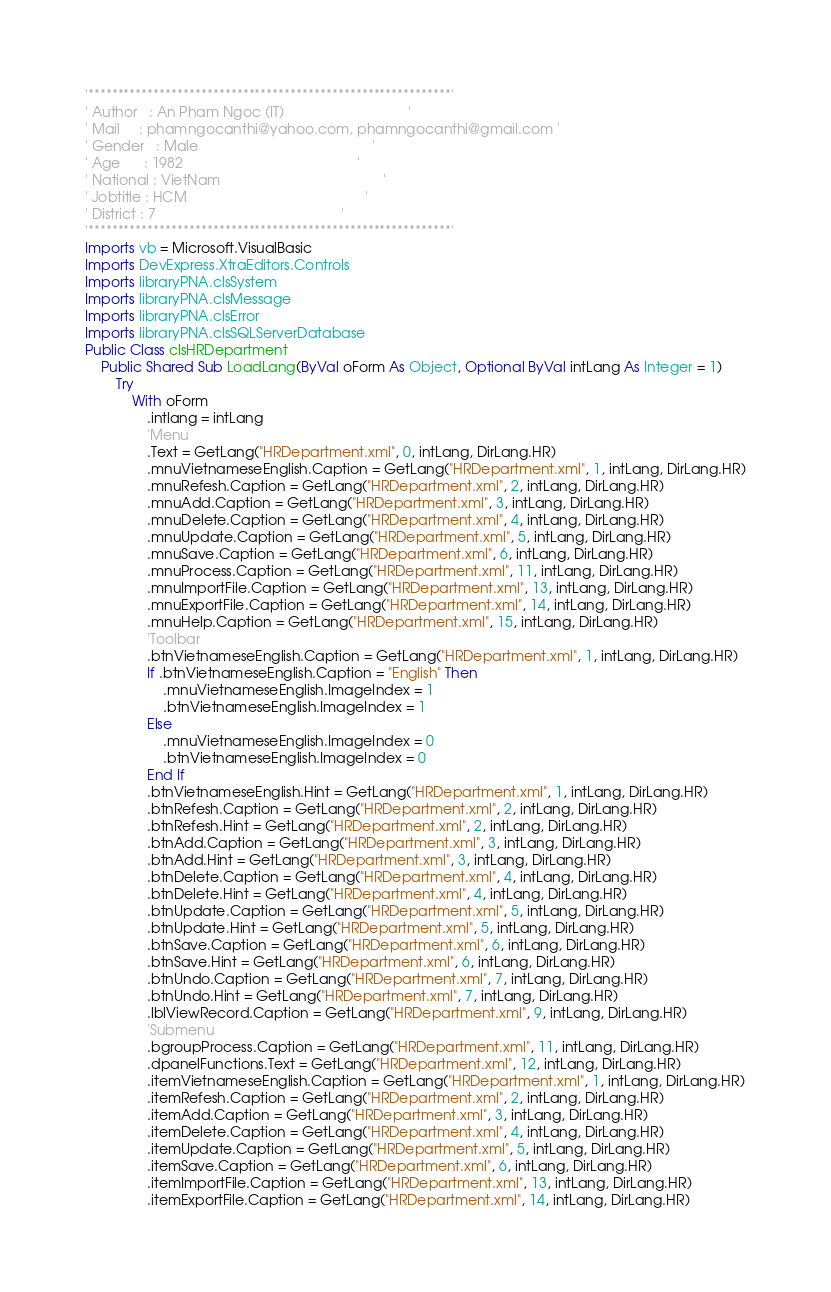Convert code to text. <code><loc_0><loc_0><loc_500><loc_500><_VisualBasic_>'*************************************************************'
' Author   : An Pham Ngoc (IT)                                ' 
' Mail     : phamngocanthi@yahoo.com, phamngocanthi@gmail.com ' 
' Gender   : Male                                             '
' Age      : 1982                                             '
' National : VietNam                                          ' 
' Jobtitle : HCM                                              ' 
' District : 7                                                ' 
'*************************************************************'
Imports vb = Microsoft.VisualBasic
Imports DevExpress.XtraEditors.Controls
Imports libraryPNA.clsSystem
Imports libraryPNA.clsMessage
Imports libraryPNA.clsError
Imports libraryPNA.clsSQLServerDatabase
Public Class clsHRDepartment
    Public Shared Sub LoadLang(ByVal oForm As Object, Optional ByVal intLang As Integer = 1)
        Try
            With oForm
                .intlang = intLang
                'Menu
                .Text = GetLang("HRDepartment.xml", 0, intLang, DirLang.HR)
                .mnuVietnameseEnglish.Caption = GetLang("HRDepartment.xml", 1, intLang, DirLang.HR)
                .mnuRefesh.Caption = GetLang("HRDepartment.xml", 2, intLang, DirLang.HR)
                .mnuAdd.Caption = GetLang("HRDepartment.xml", 3, intLang, DirLang.HR)
                .mnuDelete.Caption = GetLang("HRDepartment.xml", 4, intLang, DirLang.HR)
                .mnuUpdate.Caption = GetLang("HRDepartment.xml", 5, intLang, DirLang.HR)
                .mnuSave.Caption = GetLang("HRDepartment.xml", 6, intLang, DirLang.HR)
                .mnuProcess.Caption = GetLang("HRDepartment.xml", 11, intLang, DirLang.HR)
                .mnuImportFile.Caption = GetLang("HRDepartment.xml", 13, intLang, DirLang.HR)
                .mnuExportFile.Caption = GetLang("HRDepartment.xml", 14, intLang, DirLang.HR)
                .mnuHelp.Caption = GetLang("HRDepartment.xml", 15, intLang, DirLang.HR)
                'Toolbar
                .btnVietnameseEnglish.Caption = GetLang("HRDepartment.xml", 1, intLang, DirLang.HR)
                If .btnVietnameseEnglish.Caption = "English" Then
                    .mnuVietnameseEnglish.ImageIndex = 1
                    .btnVietnameseEnglish.ImageIndex = 1
                Else
                    .mnuVietnameseEnglish.ImageIndex = 0
                    .btnVietnameseEnglish.ImageIndex = 0
                End If
                .btnVietnameseEnglish.Hint = GetLang("HRDepartment.xml", 1, intLang, DirLang.HR)
                .btnRefesh.Caption = GetLang("HRDepartment.xml", 2, intLang, DirLang.HR)
                .btnRefesh.Hint = GetLang("HRDepartment.xml", 2, intLang, DirLang.HR)
                .btnAdd.Caption = GetLang("HRDepartment.xml", 3, intLang, DirLang.HR)
                .btnAdd.Hint = GetLang("HRDepartment.xml", 3, intLang, DirLang.HR)
                .btnDelete.Caption = GetLang("HRDepartment.xml", 4, intLang, DirLang.HR)
                .btnDelete.Hint = GetLang("HRDepartment.xml", 4, intLang, DirLang.HR)
                .btnUpdate.Caption = GetLang("HRDepartment.xml", 5, intLang, DirLang.HR)
                .btnUpdate.Hint = GetLang("HRDepartment.xml", 5, intLang, DirLang.HR)
                .btnSave.Caption = GetLang("HRDepartment.xml", 6, intLang, DirLang.HR)
                .btnSave.Hint = GetLang("HRDepartment.xml", 6, intLang, DirLang.HR)
                .btnUndo.Caption = GetLang("HRDepartment.xml", 7, intLang, DirLang.HR)
                .btnUndo.Hint = GetLang("HRDepartment.xml", 7, intLang, DirLang.HR)
                .lblViewRecord.Caption = GetLang("HRDepartment.xml", 9, intLang, DirLang.HR)
                'Submenu
                .bgroupProcess.Caption = GetLang("HRDepartment.xml", 11, intLang, DirLang.HR)
                .dpanelFunctions.Text = GetLang("HRDepartment.xml", 12, intLang, DirLang.HR)
                .itemVietnameseEnglish.Caption = GetLang("HRDepartment.xml", 1, intLang, DirLang.HR)
                .itemRefesh.Caption = GetLang("HRDepartment.xml", 2, intLang, DirLang.HR)
                .itemAdd.Caption = GetLang("HRDepartment.xml", 3, intLang, DirLang.HR)
                .itemDelete.Caption = GetLang("HRDepartment.xml", 4, intLang, DirLang.HR)
                .itemUpdate.Caption = GetLang("HRDepartment.xml", 5, intLang, DirLang.HR)
                .itemSave.Caption = GetLang("HRDepartment.xml", 6, intLang, DirLang.HR)
                .itemImportFile.Caption = GetLang("HRDepartment.xml", 13, intLang, DirLang.HR)
                .itemExportFile.Caption = GetLang("HRDepartment.xml", 14, intLang, DirLang.HR)</code> 